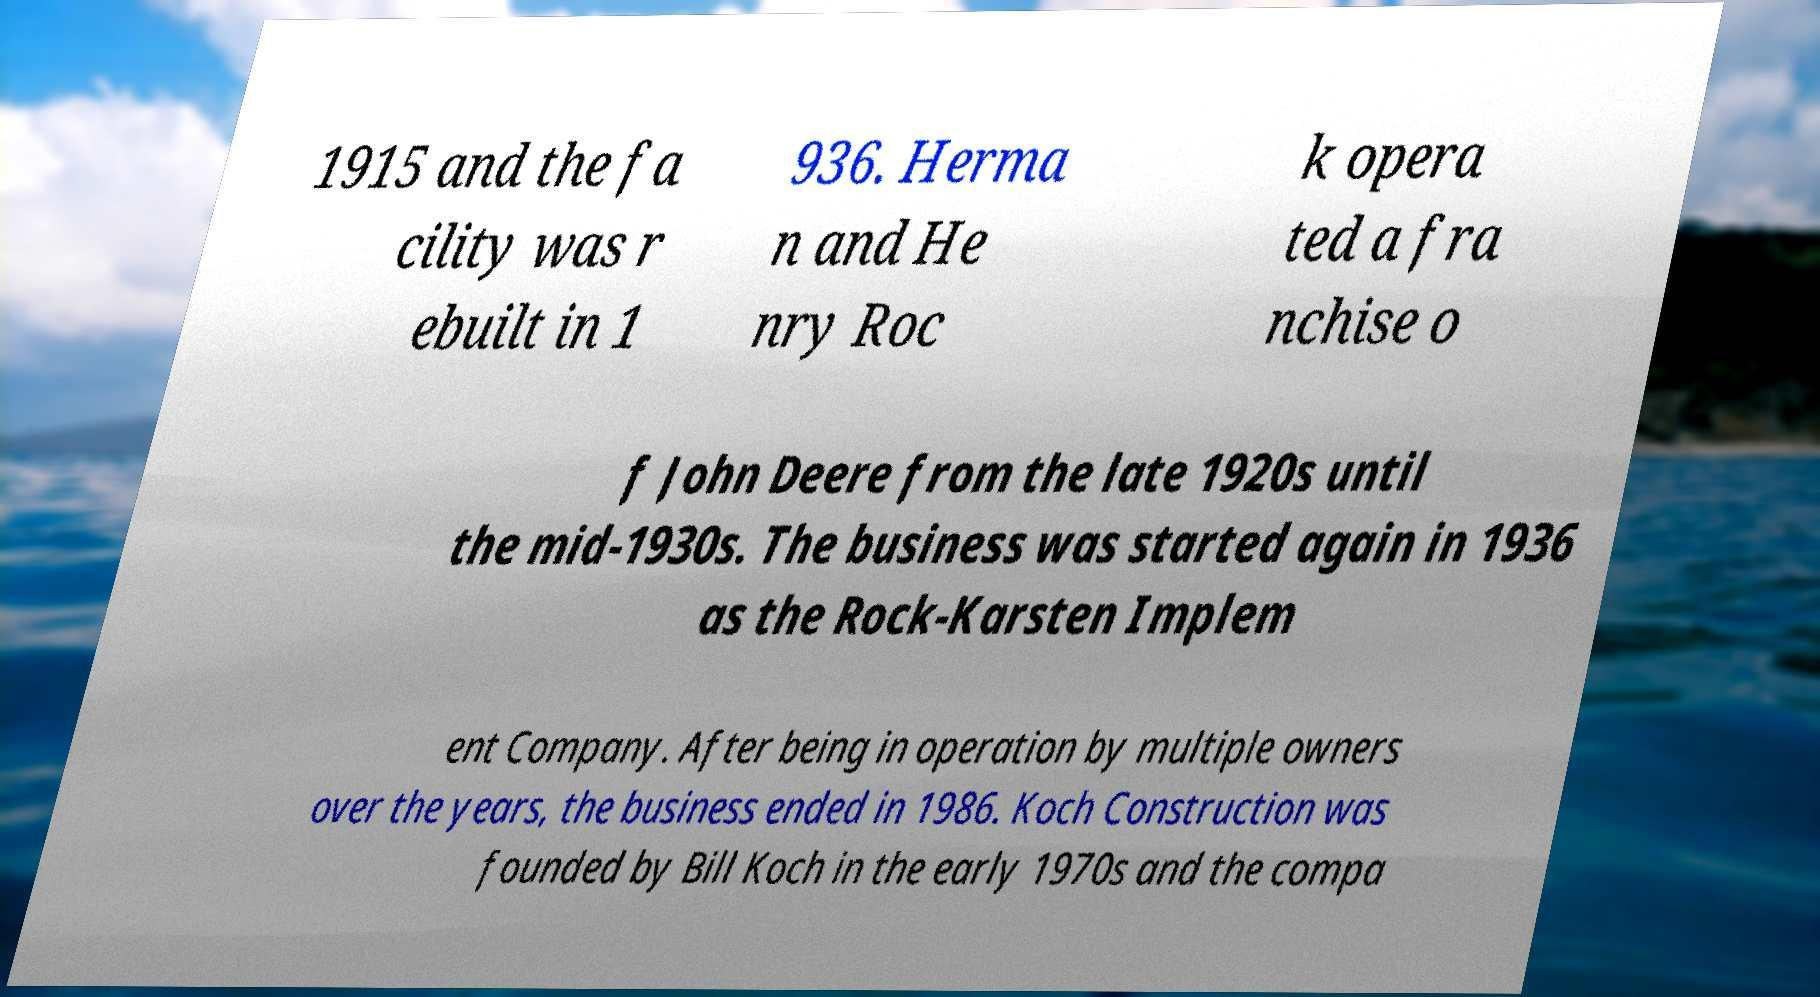Please identify and transcribe the text found in this image. 1915 and the fa cility was r ebuilt in 1 936. Herma n and He nry Roc k opera ted a fra nchise o f John Deere from the late 1920s until the mid-1930s. The business was started again in 1936 as the Rock-Karsten Implem ent Company. After being in operation by multiple owners over the years, the business ended in 1986. Koch Construction was founded by Bill Koch in the early 1970s and the compa 